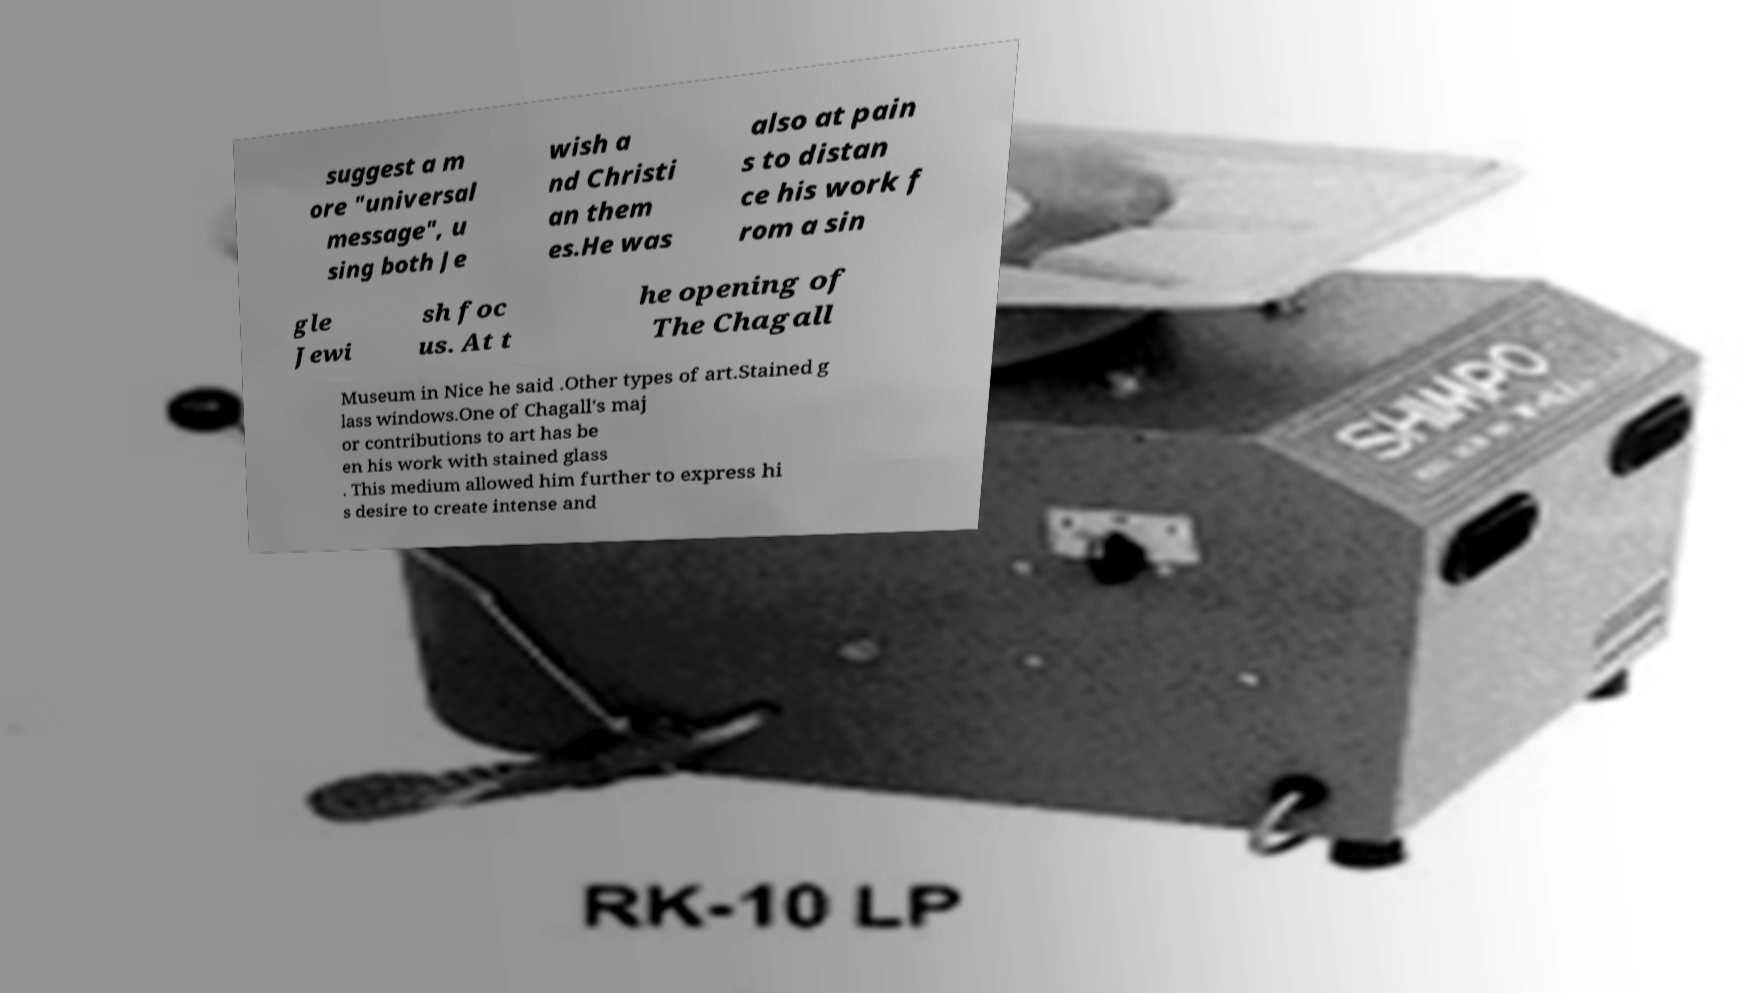Could you assist in decoding the text presented in this image and type it out clearly? suggest a m ore "universal message", u sing both Je wish a nd Christi an them es.He was also at pain s to distan ce his work f rom a sin gle Jewi sh foc us. At t he opening of The Chagall Museum in Nice he said .Other types of art.Stained g lass windows.One of Chagall's maj or contributions to art has be en his work with stained glass . This medium allowed him further to express hi s desire to create intense and 